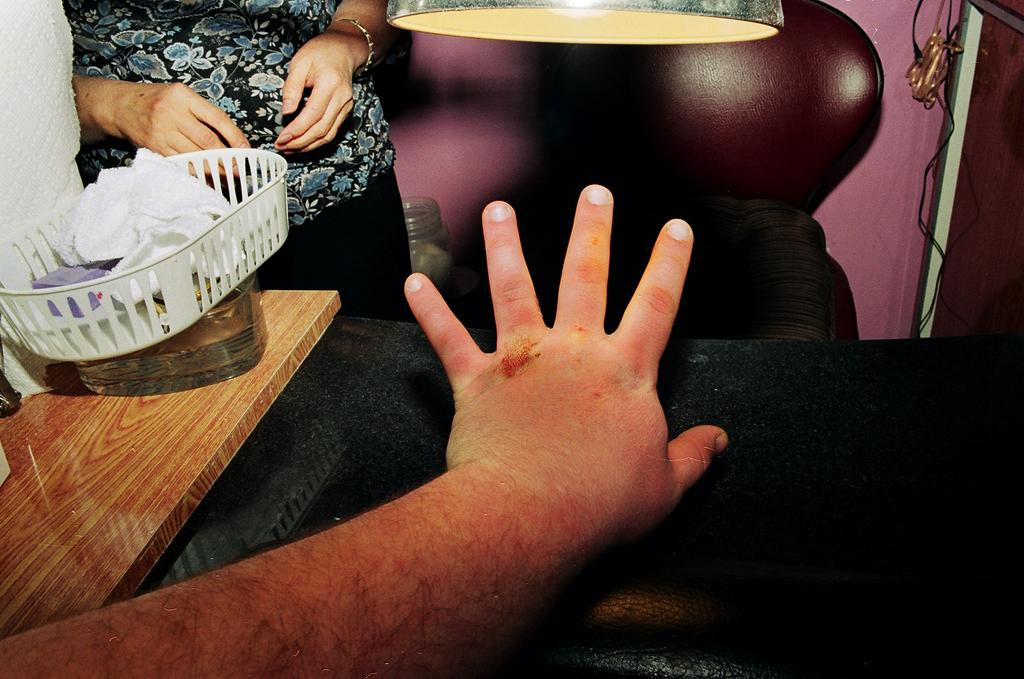How many people are in the image? There are two persons in the image. What can be seen on the table in the image? There are boxes and other objects on the table. What type of furniture is in the image? There is a chair in the image. What is the source of light in the image? There is a light in the image. What is attached to the wall in the image? There is a cable hanging from the wall. What type of fiction is the person reading in the image? There is no person reading fiction in the image; it only shows two persons, boxes, other objects, a chair, a light, and a cable hanging from the wall. What disease is the person suffering from in the image? There is no indication of any disease or illness in the image; it only shows two persons, boxes, other objects, a chair, a light, and a cable hanging from the wall. 